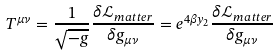<formula> <loc_0><loc_0><loc_500><loc_500>T ^ { \mu \nu } = \frac { 1 } { \sqrt { - g } } \frac { \delta \mathcal { L } _ { m a t t e r } } { \delta g _ { \mu \nu } } = e ^ { 4 \beta y _ { 2 } } \frac { \delta \mathcal { L } _ { m a t t e r } } { \delta g _ { \mu \nu } }</formula> 